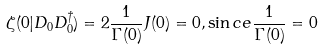<formula> <loc_0><loc_0><loc_500><loc_500>\zeta ( 0 | D _ { 0 } D _ { 0 } ^ { \dagger } ) = 2 \frac { 1 } { \Gamma ( 0 ) } J ( 0 ) = 0 , \sin c e \frac { 1 } { \Gamma ( 0 ) } = 0</formula> 